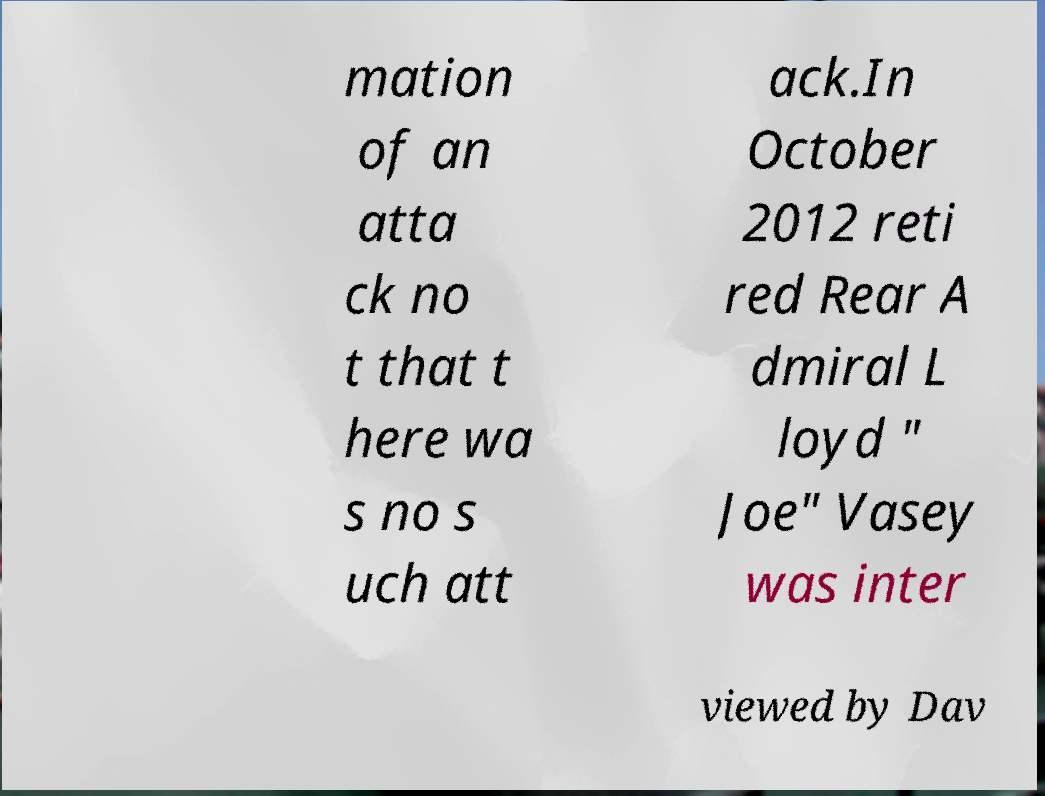There's text embedded in this image that I need extracted. Can you transcribe it verbatim? mation of an atta ck no t that t here wa s no s uch att ack.In October 2012 reti red Rear A dmiral L loyd " Joe" Vasey was inter viewed by Dav 